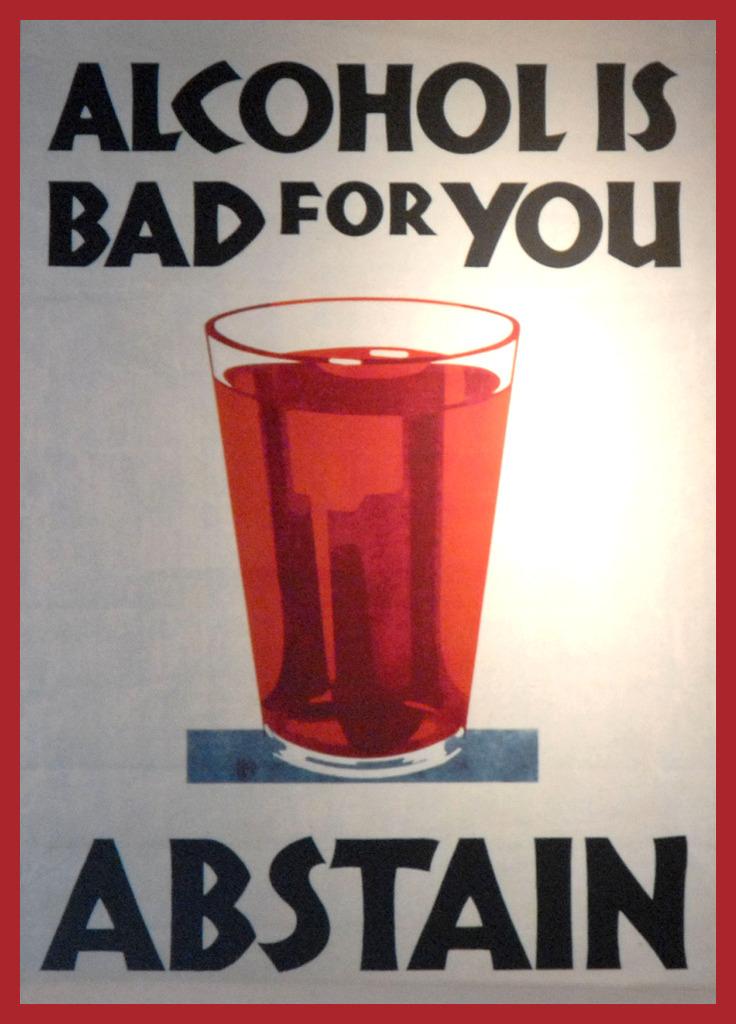Is that alcohol or juice?
Keep it short and to the point. Alcohol. According to the poster, why should you abstain from alcohol?
Your response must be concise. It's bad for you. 